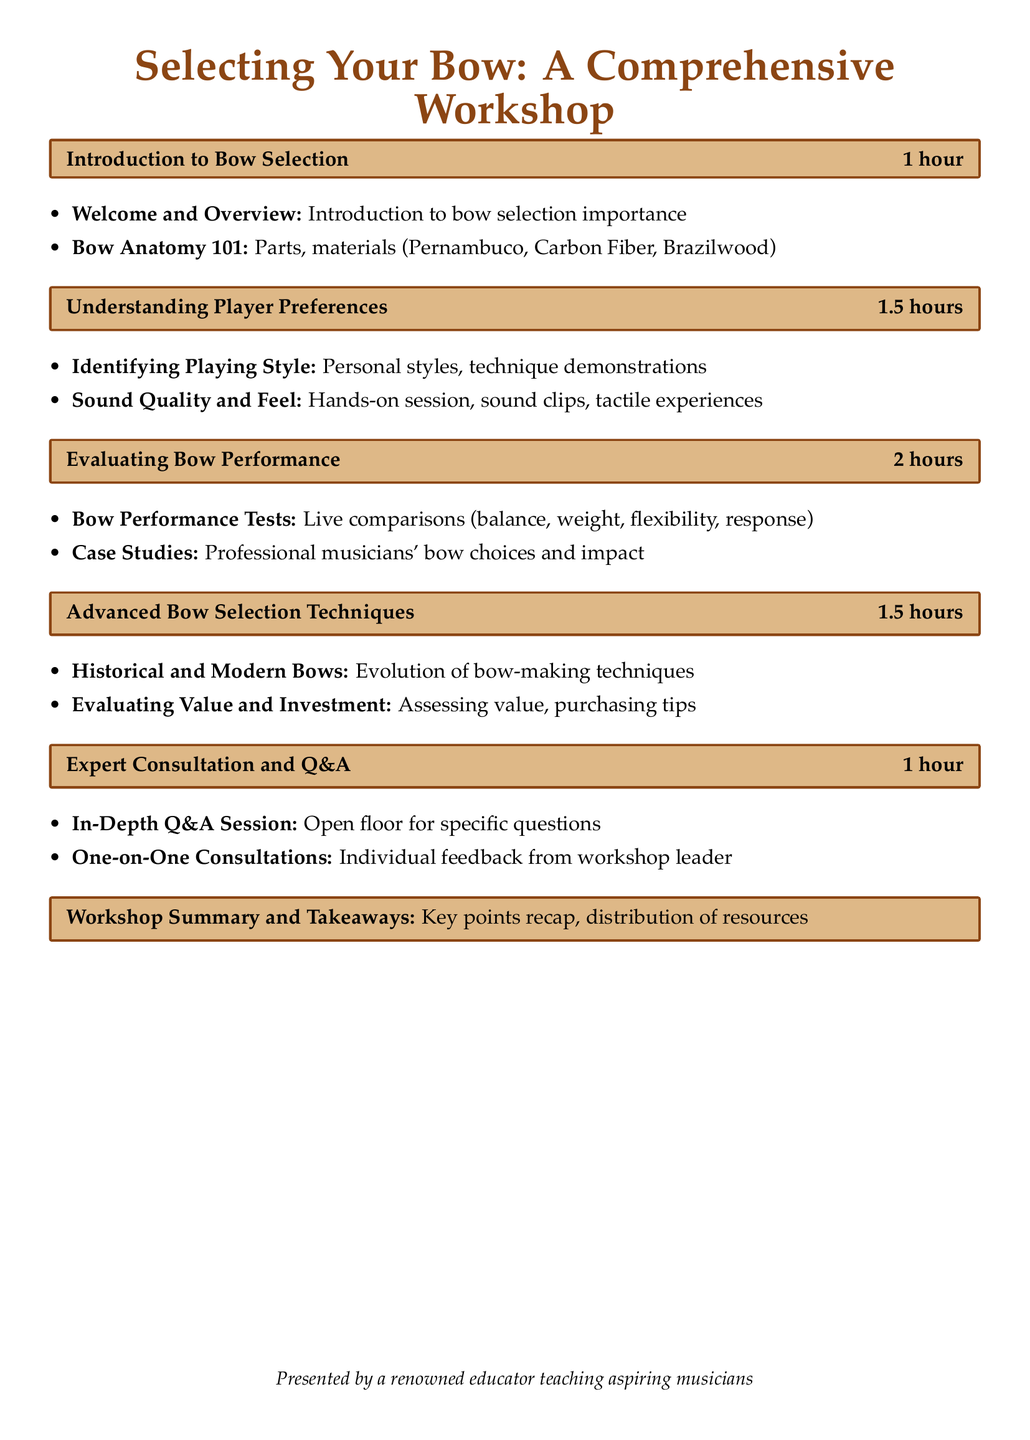What is the duration of the first session? The document states the first session, "Introduction to Bow Selection," lasts 1 hour.
Answer: 1 hour What is covered in the session titled "Understanding Player Preferences"? This session includes identifying playing style and sound quality, along with hands-on experiences.
Answer: Identifying Playing Style, Sound Quality and Feel How long is the "Evaluating Bow Performance" session? The document indicates that the "Evaluating Bow Performance" session takes 2 hours.
Answer: 2 hours What is the main focus of the "Expert Consultation and Q&A" session? This session is primarily for in-depth Q&A and one-on-one consultations.
Answer: In-Depth Q&A Session, One-on-One Consultations What materials are mentioned in the "Introduction to Bow Selection"? The materials discussed in this session include Pernambuco, Carbon Fiber, and Brazilwood.
Answer: Pernambuco, Carbon Fiber, Brazilwood How many total hours will the workshop last? The total duration is calculated by adding all the session times, which sums up to 7 hours.
Answer: 7 hours What is the purpose of the workshop as highlighted in the document? The document articulates that the workshop is focused on bow selection for aspiring musicians.
Answer: Selecting Your Bow Which session includes hands-on experience? The document specifies that the "Understanding Player Preferences" session includes a hands-on experience.
Answer: Understanding Player Preferences 